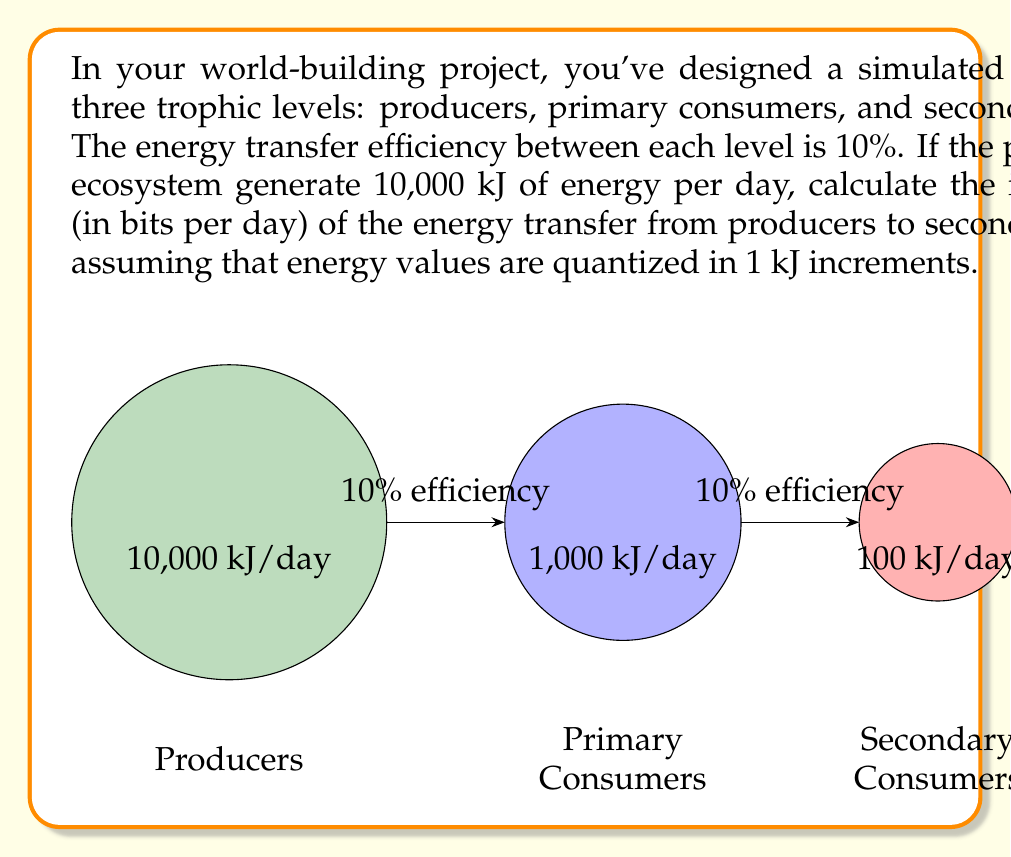Provide a solution to this math problem. Let's approach this step-by-step:

1) First, we need to calculate the energy reaching the secondary consumers:
   - Producers generate 10,000 kJ/day
   - Primary consumers receive 10% of this: 10,000 * 0.1 = 1,000 kJ/day
   - Secondary consumers receive 10% of 1,000 kJ: 1,000 * 0.1 = 100 kJ/day

2) The information rate is related to the number of possible states the system can be in. In this case, it's the number of possible energy values the secondary consumers can receive.

3) Since energy is quantized in 1 kJ increments, there are 101 possible states (0 to 100 kJ).

4) The information content of a system with N equally probable states is given by:

   $$I = \log_2(N)$$

   Where I is the information content in bits.

5) In our case:

   $$I = \log_2(101) \approx 6.658 \text{ bits}$$

6) This is the information content per day. To get the information rate, we don't need to do anything further as we're already working with daily values.

Therefore, the information rate of the energy transfer from producers to secondary consumers is approximately 6.658 bits per day.
Answer: $6.658$ bits/day 